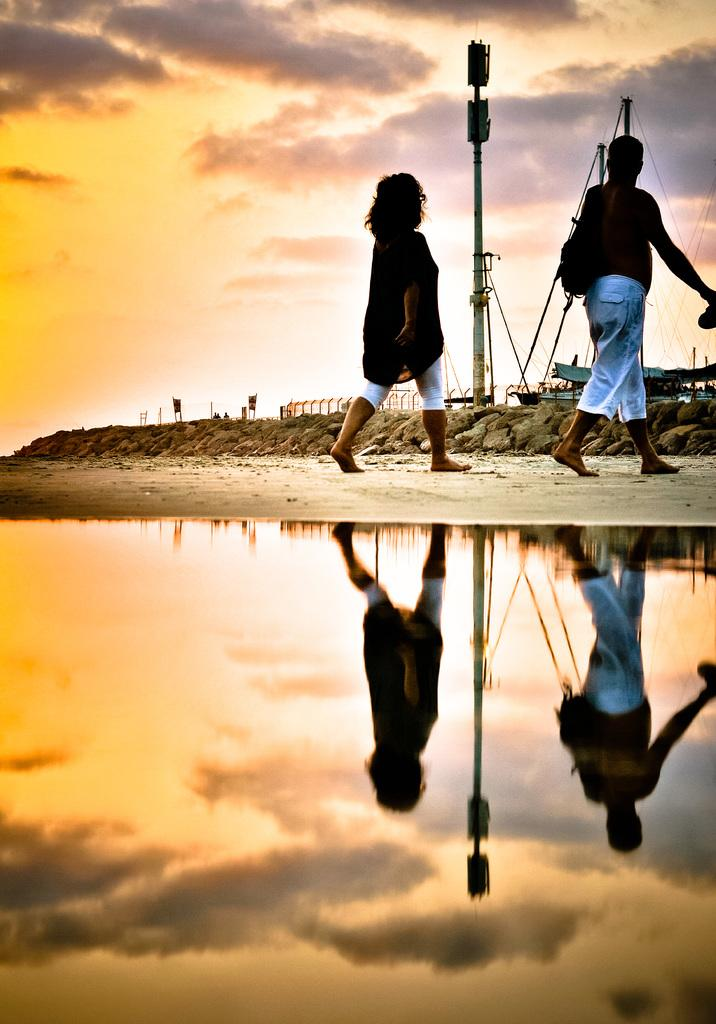What are the two people in the image doing? The two people in the image are walking. What is at the bottom of the image? There is water at the bottom of the image. What can be seen in the background of the image? There is a pole and a boat in the background of the image, as well as the sky. What type of twig can be seen in the image? There is no twig present in the image. What is the texture of the boat in the image? The provided facts do not mention the texture of the boat, so it cannot be determined from the image. 